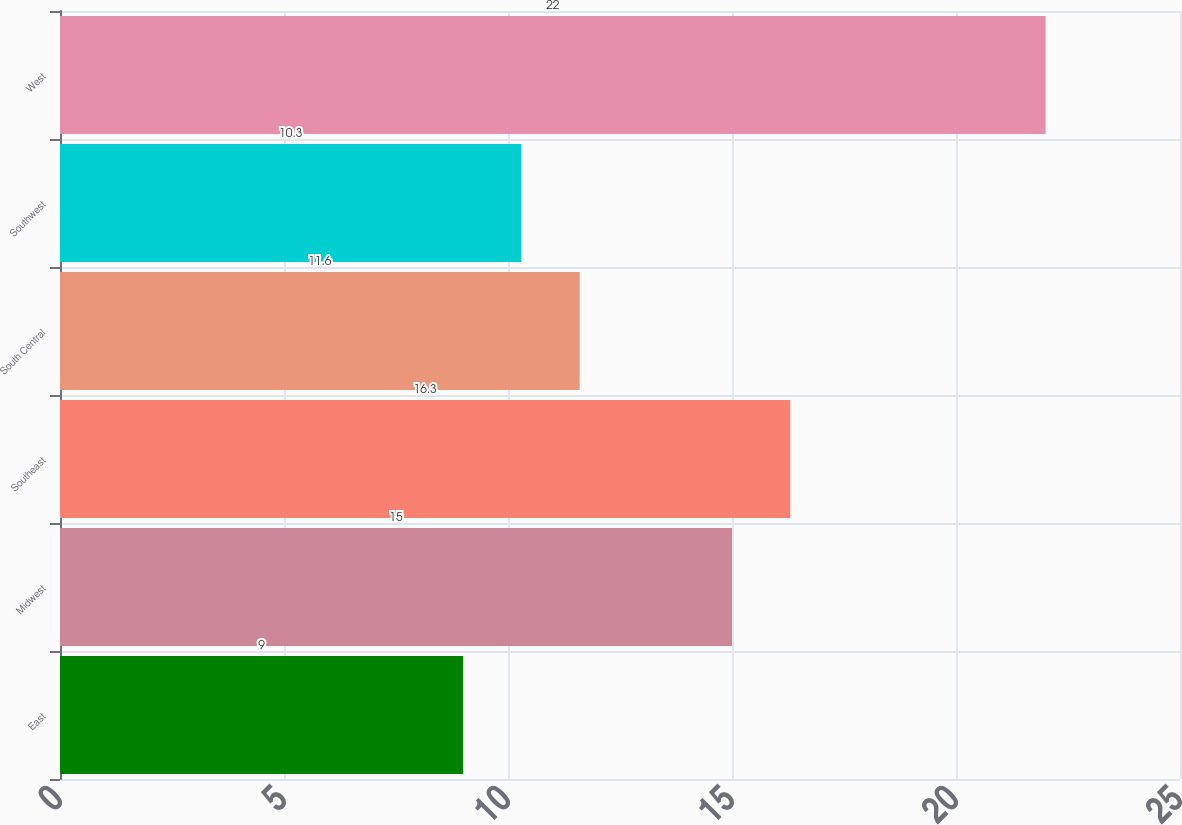<chart> <loc_0><loc_0><loc_500><loc_500><bar_chart><fcel>East<fcel>Midwest<fcel>Southeast<fcel>South Central<fcel>Southwest<fcel>West<nl><fcel>9<fcel>15<fcel>16.3<fcel>11.6<fcel>10.3<fcel>22<nl></chart> 